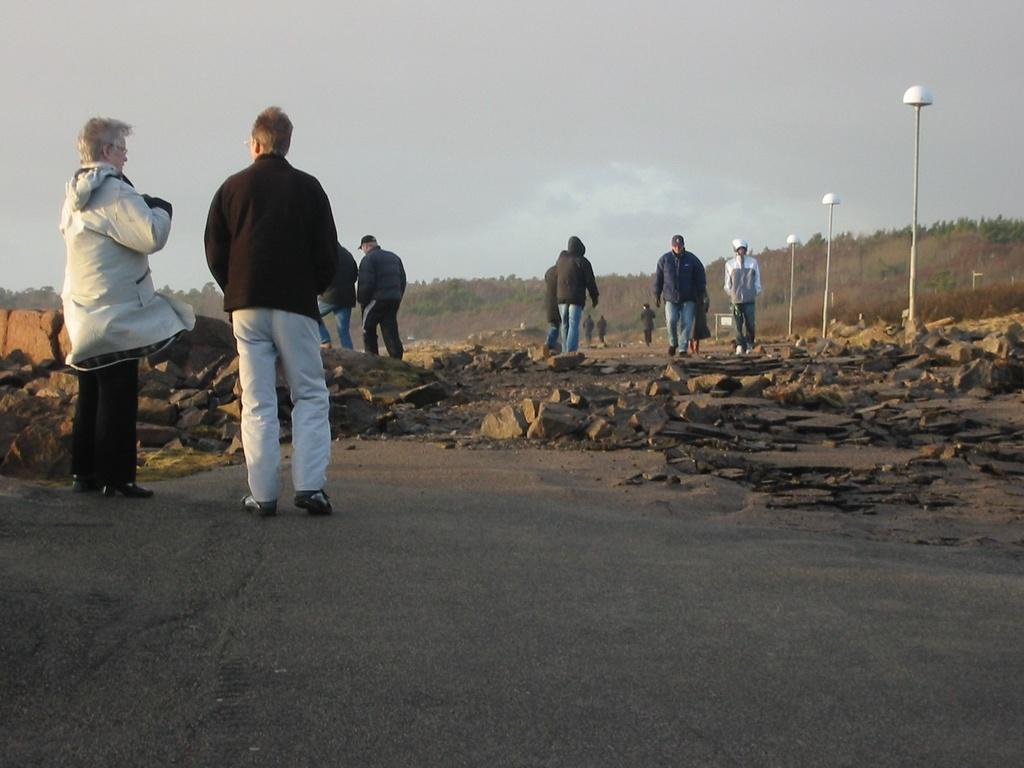Describe this image in one or two sentences. In the foreground of the picture we can see two persons and road. In the middle of the picture there are people, street light and a devastated road. In the background there are trees. At the top there is sky. 